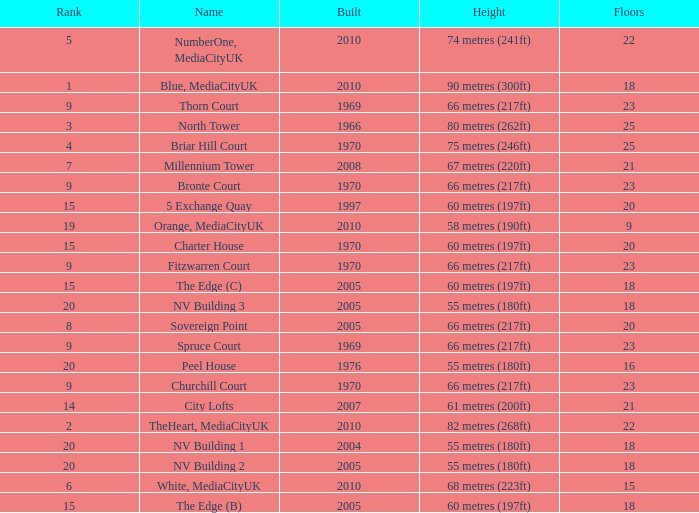What is the total number of Built, when Floors is less than 22, when Rank is less than 8, and when Name is White, Mediacityuk? 1.0. Could you parse the entire table? {'header': ['Rank', 'Name', 'Built', 'Height', 'Floors'], 'rows': [['5', 'NumberOne, MediaCityUK', '2010', '74 metres (241ft)', '22'], ['1', 'Blue, MediaCityUK', '2010', '90 metres (300ft)', '18'], ['9', 'Thorn Court', '1969', '66 metres (217ft)', '23'], ['3', 'North Tower', '1966', '80 metres (262ft)', '25'], ['4', 'Briar Hill Court', '1970', '75 metres (246ft)', '25'], ['7', 'Millennium Tower', '2008', '67 metres (220ft)', '21'], ['9', 'Bronte Court', '1970', '66 metres (217ft)', '23'], ['15', '5 Exchange Quay', '1997', '60 metres (197ft)', '20'], ['19', 'Orange, MediaCityUK', '2010', '58 metres (190ft)', '9'], ['15', 'Charter House', '1970', '60 metres (197ft)', '20'], ['9', 'Fitzwarren Court', '1970', '66 metres (217ft)', '23'], ['15', 'The Edge (C)', '2005', '60 metres (197ft)', '18'], ['20', 'NV Building 3', '2005', '55 metres (180ft)', '18'], ['8', 'Sovereign Point', '2005', '66 metres (217ft)', '20'], ['9', 'Spruce Court', '1969', '66 metres (217ft)', '23'], ['20', 'Peel House', '1976', '55 metres (180ft)', '16'], ['9', 'Churchill Court', '1970', '66 metres (217ft)', '23'], ['14', 'City Lofts', '2007', '61 metres (200ft)', '21'], ['2', 'TheHeart, MediaCityUK', '2010', '82 metres (268ft)', '22'], ['20', 'NV Building 1', '2004', '55 metres (180ft)', '18'], ['20', 'NV Building 2', '2005', '55 metres (180ft)', '18'], ['6', 'White, MediaCityUK', '2010', '68 metres (223ft)', '15'], ['15', 'The Edge (B)', '2005', '60 metres (197ft)', '18']]} 